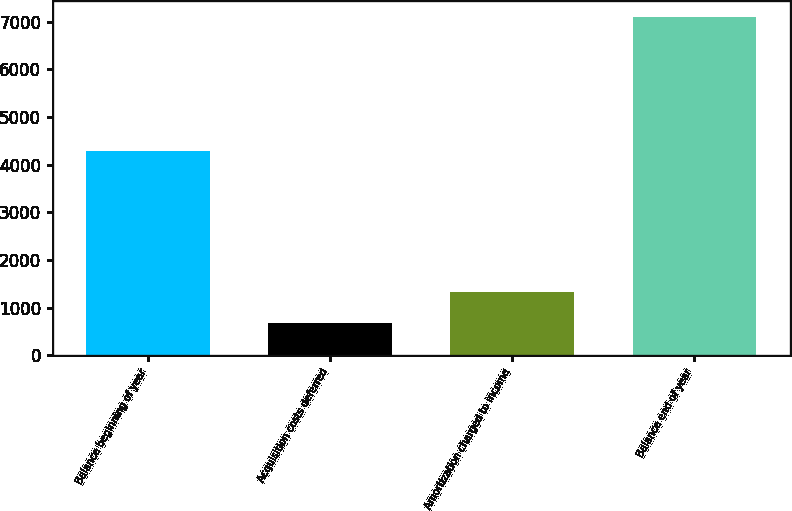<chart> <loc_0><loc_0><loc_500><loc_500><bar_chart><fcel>Balance beginning of year<fcel>Acquisition costs deferred<fcel>Amortization charged to income<fcel>Balance end of year<nl><fcel>4291<fcel>684<fcel>1324.5<fcel>7089<nl></chart> 